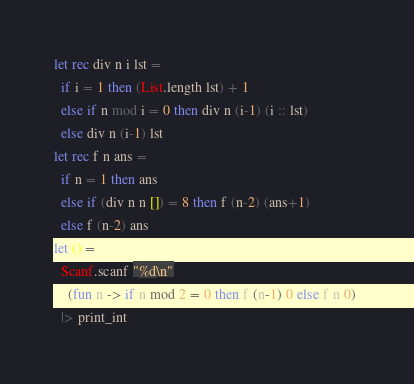<code> <loc_0><loc_0><loc_500><loc_500><_OCaml_>let rec div n i lst =
  if i = 1 then (List.length lst) + 1
  else if n mod i = 0 then div n (i-1) (i :: lst)
  else div n (i-1) lst
let rec f n ans =
  if n = 1 then ans
  else if (div n n []) = 8 then f (n-2) (ans+1)
  else f (n-2) ans
let () =
  Scanf.scanf "%d\n"
    (fun n -> if n mod 2 = 0 then f (n-1) 0 else f n 0) 
  |> print_int</code> 